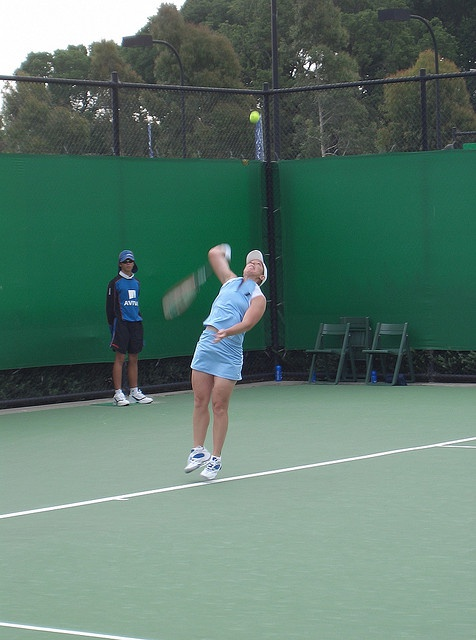Describe the objects in this image and their specific colors. I can see people in white, gray, darkgray, and lightblue tones, people in white, black, gray, and blue tones, chair in white, black, teal, and darkblue tones, chair in white, black, teal, and purple tones, and tennis racket in white, gray, teal, and darkgreen tones in this image. 